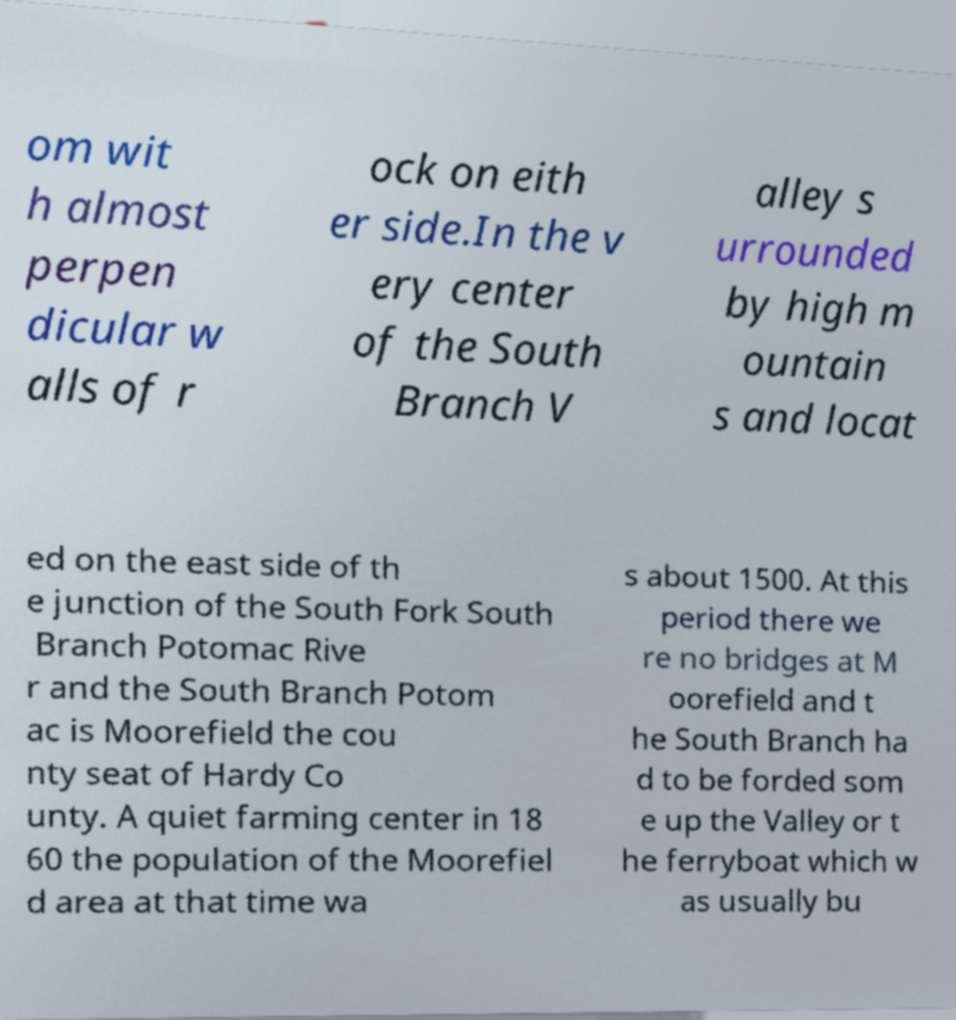Could you assist in decoding the text presented in this image and type it out clearly? om wit h almost perpen dicular w alls of r ock on eith er side.In the v ery center of the South Branch V alley s urrounded by high m ountain s and locat ed on the east side of th e junction of the South Fork South Branch Potomac Rive r and the South Branch Potom ac is Moorefield the cou nty seat of Hardy Co unty. A quiet farming center in 18 60 the population of the Moorefiel d area at that time wa s about 1500. At this period there we re no bridges at M oorefield and t he South Branch ha d to be forded som e up the Valley or t he ferryboat which w as usually bu 